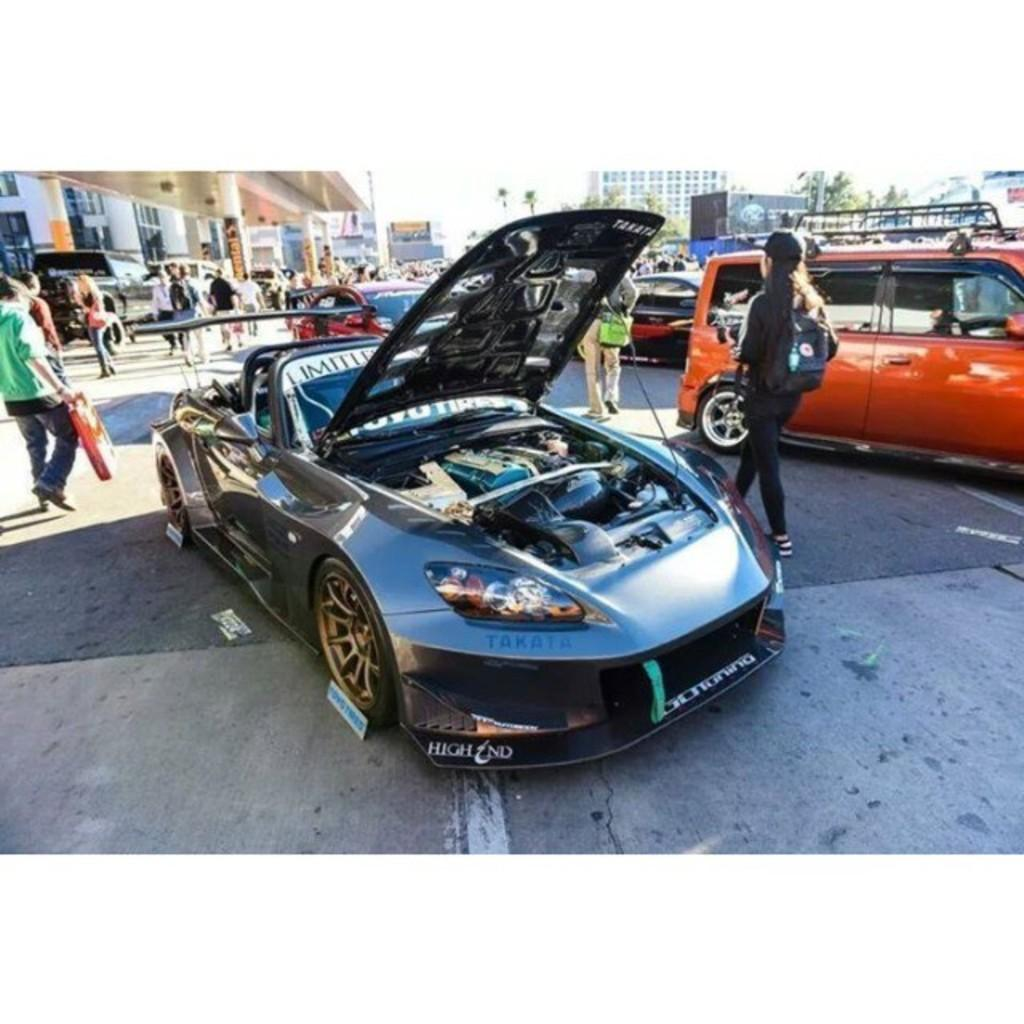What types of objects are present in the image? There are vehicles in the image. What are the people in the image doing? The people are on the floor in the image. What can be seen in the distance in the image? There are buildings and a tree in the background of the image. What part of the natural environment is visible in the image? The sky is visible in the background of the image. What type of lettuce can be seen growing near the tree in the image? There is no lettuce present in the image; it only features vehicles, people, buildings, a tree, and the sky. Can you tell me how many sheep are visible in the image? There are no sheep present in the image. 